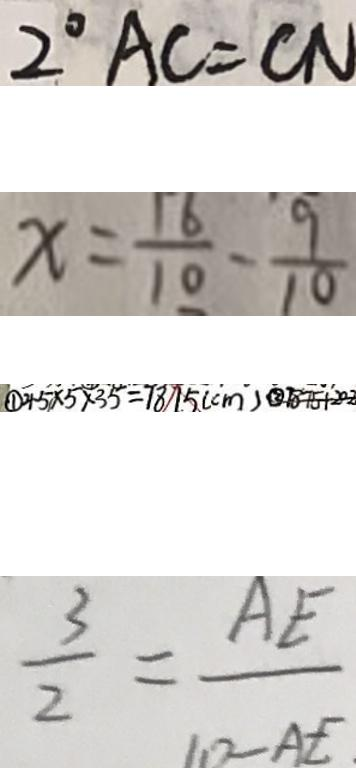<formula> <loc_0><loc_0><loc_500><loc_500>2 ^ { \circ } A C = C N 
 x = \frac { 1 6 } { 1 0 } - \frac { 9 } { 1 0 } 
 \textcircled { 1 } 4 . 5 \times 5 \times 3 5 = 7 8 7 . 5 ( c m ) \textcircled { 2 } 7 8 7 5 + 2 0 2 
 \frac { 3 } { 2 } = \frac { A E } { 1 0 - A E } .</formula> 